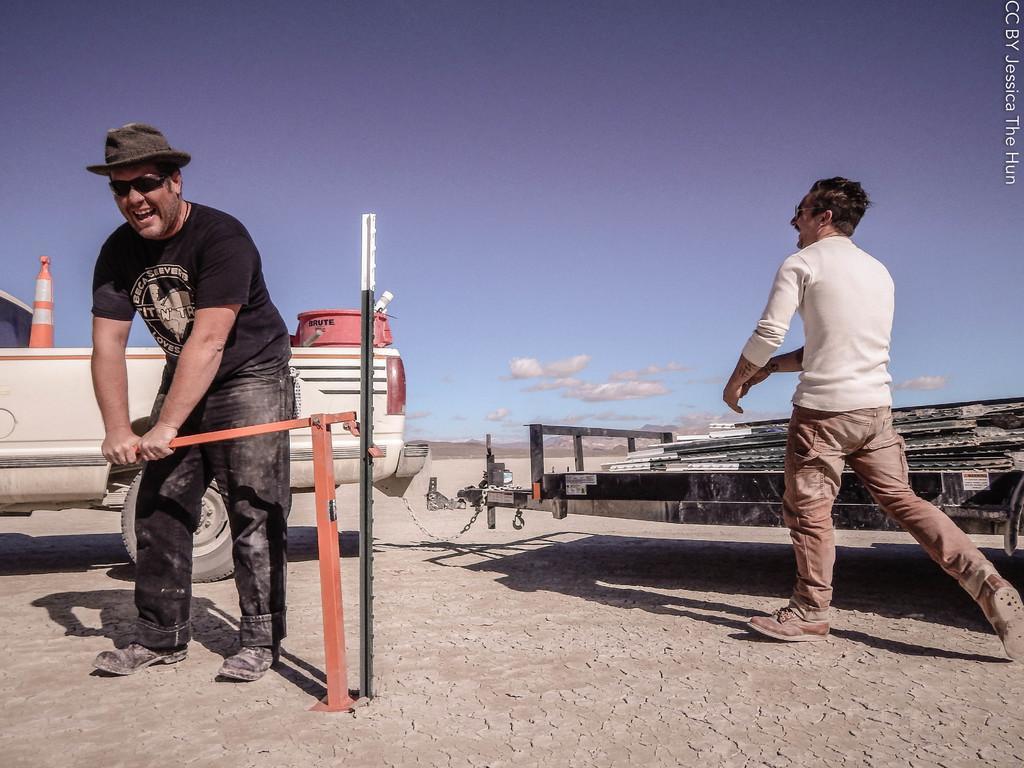In one or two sentences, can you explain what this image depicts? In the picture I can see people are on the floor, behind we can see vehicles are attached with chain, one person is holding an object. 